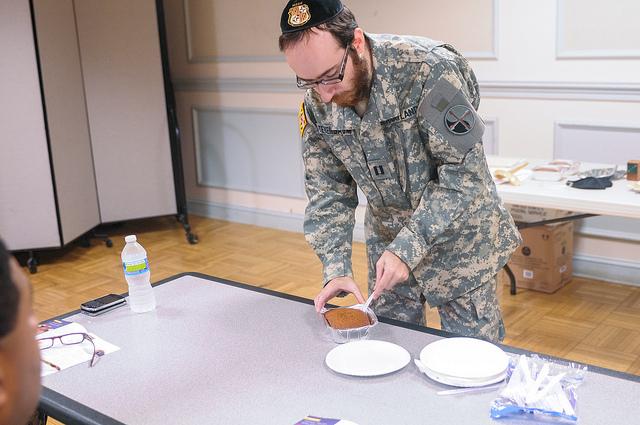Can you see a box in this photo?
Be succinct. Yes. Are there multiple utensils in the photo?
Write a very short answer. Yes. Is the man in the military?
Give a very brief answer. Yes. 